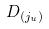Convert formula to latex. <formula><loc_0><loc_0><loc_500><loc_500>D _ { ( j _ { u } ) }</formula> 